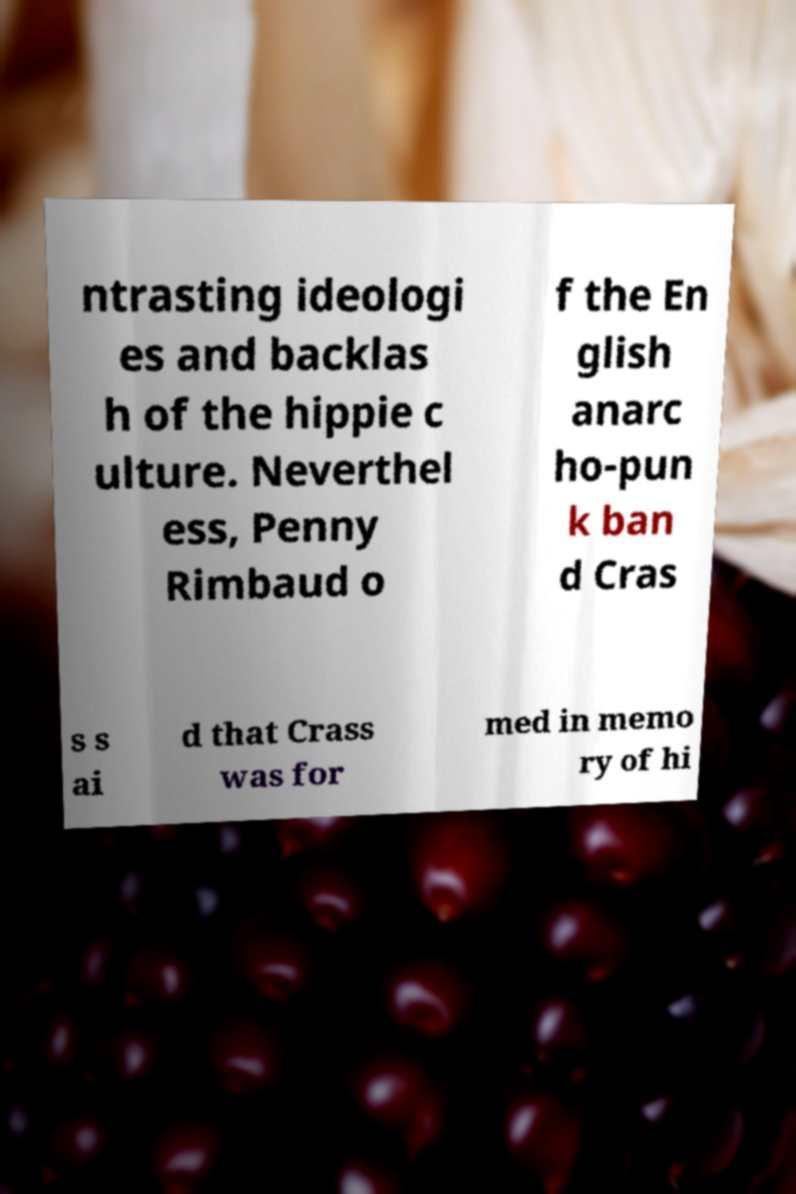What messages or text are displayed in this image? I need them in a readable, typed format. ntrasting ideologi es and backlas h of the hippie c ulture. Neverthel ess, Penny Rimbaud o f the En glish anarc ho-pun k ban d Cras s s ai d that Crass was for med in memo ry of hi 